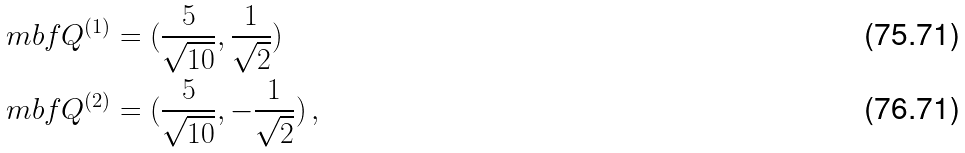Convert formula to latex. <formula><loc_0><loc_0><loc_500><loc_500>\ m b f Q ^ { ( 1 ) } & = ( \frac { 5 } { \sqrt { 1 0 } } , \frac { 1 } { \sqrt { 2 } } ) \\ \ m b f Q ^ { ( 2 ) } & = ( \frac { 5 } { \sqrt { 1 0 } } , - \frac { 1 } { \sqrt { 2 } } ) \, ,</formula> 